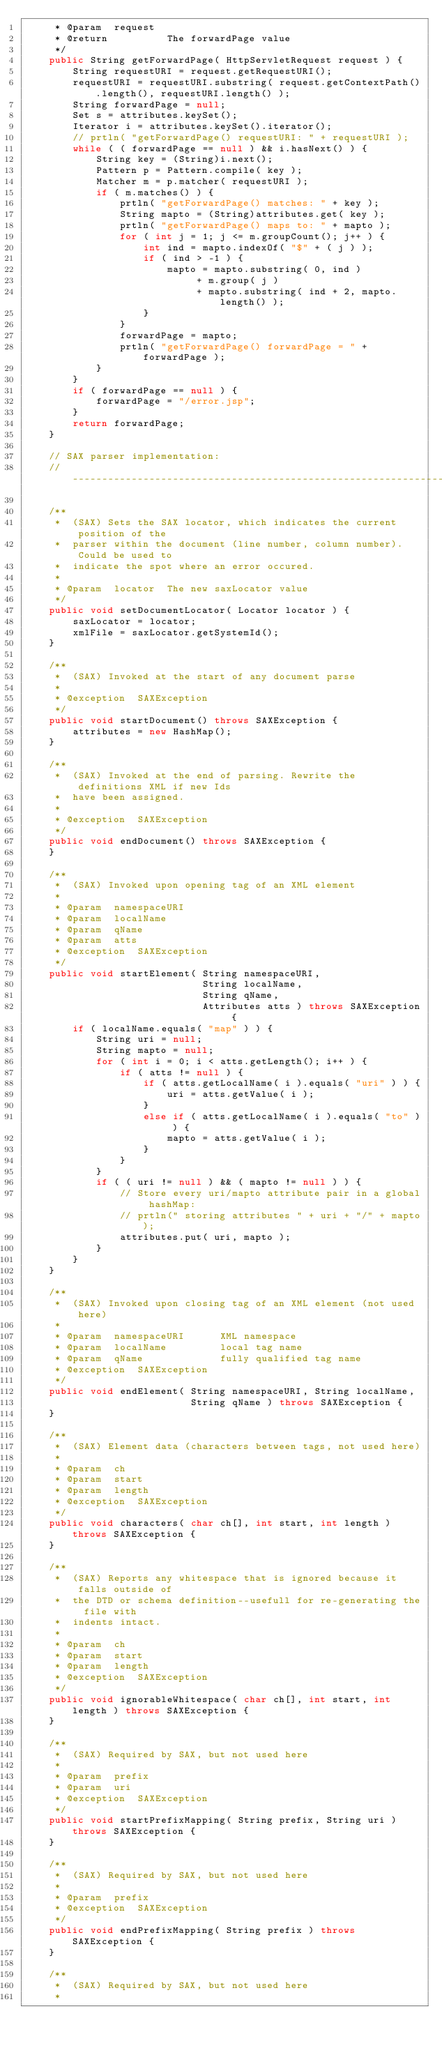<code> <loc_0><loc_0><loc_500><loc_500><_Java_>	 * @param  request
	 * @return          The forwardPage value
	 */
	public String getForwardPage( HttpServletRequest request ) {
		String requestURI = request.getRequestURI();
		requestURI = requestURI.substring( request.getContextPath().length(), requestURI.length() );
		String forwardPage = null;
		Set s = attributes.keySet();
		Iterator i = attributes.keySet().iterator();
		// prtln( "getForwardPage() requestURI: " + requestURI );
		while ( ( forwardPage == null ) && i.hasNext() ) {
			String key = (String)i.next();
			Pattern p = Pattern.compile( key );
			Matcher m = p.matcher( requestURI );
			if ( m.matches() ) {
				prtln( "getForwardPage() matches: " + key );
				String mapto = (String)attributes.get( key );
				prtln( "getForwardPage() maps to: " + mapto );
				for ( int j = 1; j <= m.groupCount(); j++ ) {
					int ind = mapto.indexOf( "$" + ( j ) );
					if ( ind > -1 ) {
						mapto = mapto.substring( 0, ind )
							 + m.group( j )
							 + mapto.substring( ind + 2, mapto.length() );
					}
				}
				forwardPage = mapto;
				prtln( "getForwardPage() forwardPage = " + forwardPage );
			}
		}
		if ( forwardPage == null ) {
			forwardPage = "/error.jsp";
		}
		return forwardPage;
	}

	// SAX parser implementation:
	//----------------------------------------------------------------------------------

	/**
	 *  (SAX) Sets the SAX locator, which indicates the current position of the
	 *  parser within the document (line number, column number). Could be used to
	 *  indicate the spot where an error occured.
	 *
	 * @param  locator  The new saxLocator value
	 */
	public void setDocumentLocator( Locator locator ) {
		saxLocator = locator;
		xmlFile = saxLocator.getSystemId();
	}

	/**
	 *  (SAX) Invoked at the start of any document parse
	 *
	 * @exception  SAXException
	 */
	public void startDocument() throws SAXException {
		attributes = new HashMap();
	}

	/**
	 *  (SAX) Invoked at the end of parsing. Rewrite the definitions XML if new Ids
	 *  have been assigned.
	 *
	 * @exception  SAXException
	 */
	public void endDocument() throws SAXException {
	}

	/**
	 *  (SAX) Invoked upon opening tag of an XML element
	 *
	 * @param  namespaceURI
	 * @param  localName
	 * @param  qName
	 * @param  atts
	 * @exception  SAXException
	 */
	public void startElement( String namespaceURI,
	                          String localName,
	                          String qName,
	                          Attributes atts ) throws SAXException {
		if ( localName.equals( "map" ) ) {
			String uri = null;
			String mapto = null;
			for ( int i = 0; i < atts.getLength(); i++ ) {
				if ( atts != null ) {
					if ( atts.getLocalName( i ).equals( "uri" ) ) {
						uri = atts.getValue( i );
					}
					else if ( atts.getLocalName( i ).equals( "to" ) ) {
						mapto = atts.getValue( i );
					}
				}
			}
			if ( ( uri != null ) && ( mapto != null ) ) {
				// Store every uri/mapto attribute pair in a global hashMap:
				// prtln(" storing attributes " + uri + "/" + mapto);
				attributes.put( uri, mapto );
			}
		}
	}

	/**
	 *  (SAX) Invoked upon closing tag of an XML element (not used here)
	 *
	 * @param  namespaceURI      XML namespace
	 * @param  localName         local tag name
	 * @param  qName             fully qualified tag name
	 * @exception  SAXException
	 */
	public void endElement( String namespaceURI, String localName,
	                        String qName ) throws SAXException {
	}

	/**
	 *  (SAX) Element data (characters between tags, not used here)
	 *
	 * @param  ch
	 * @param  start
	 * @param  length
	 * @exception  SAXException
	 */
	public void characters( char ch[], int start, int length ) throws SAXException {
	}

	/**
	 *  (SAX) Reports any whitespace that is ignored because it falls outside of
	 *  the DTD or schema definition--usefull for re-generating the file with
	 *  indents intact.
	 *
	 * @param  ch
	 * @param  start
	 * @param  length
	 * @exception  SAXException
	 */
	public void ignorableWhitespace( char ch[], int start, int length ) throws SAXException {
	}

	/**
	 *  (SAX) Required by SAX, but not used here
	 *
	 * @param  prefix
	 * @param  uri
	 * @exception  SAXException
	 */
	public void startPrefixMapping( String prefix, String uri ) throws SAXException {
	}

	/**
	 *  (SAX) Required by SAX, but not used here
	 *
	 * @param  prefix
	 * @exception  SAXException
	 */
	public void endPrefixMapping( String prefix ) throws SAXException {
	}

	/**
	 *  (SAX) Required by SAX, but not used here
	 *</code> 